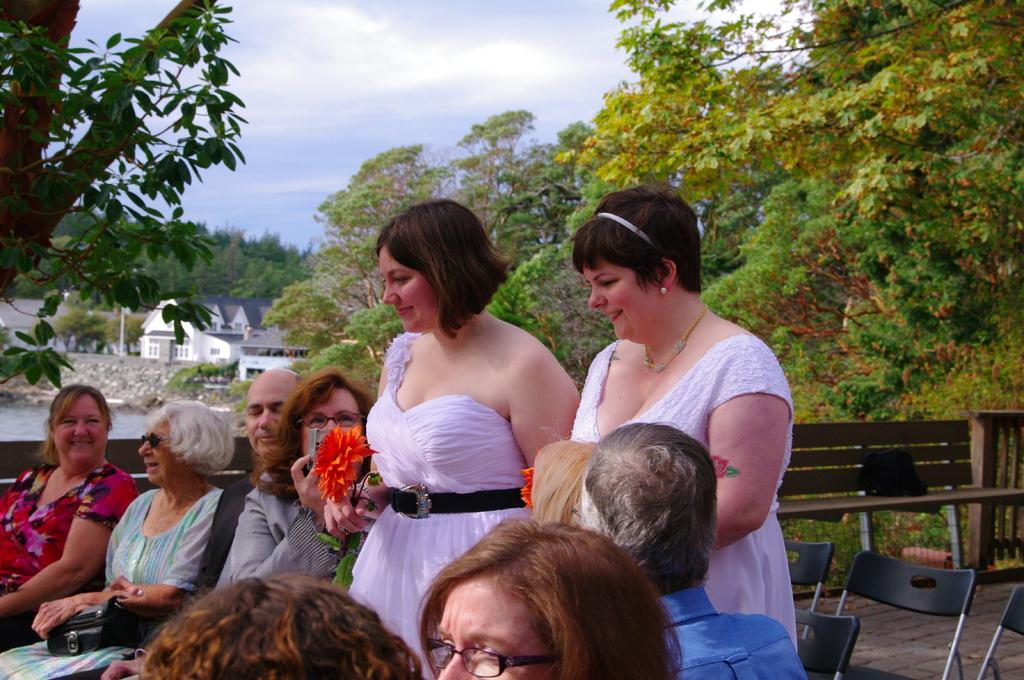Can you describe this image briefly? This image is taken outdoors. At the top of the image there is a sky with clouds. In the background there are a few trees and plants on the ground and there are a few houses. In the middle of the image a few people are sitting on the chairs and two women are standing on the floor and there are a few empty chairs. There is an empty bench. 